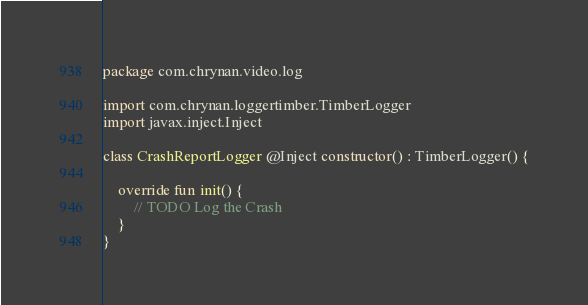<code> <loc_0><loc_0><loc_500><loc_500><_Kotlin_>package com.chrynan.video.log

import com.chrynan.loggertimber.TimberLogger
import javax.inject.Inject

class CrashReportLogger @Inject constructor() : TimberLogger() {

    override fun init() {
        // TODO Log the Crash
    }
}</code> 